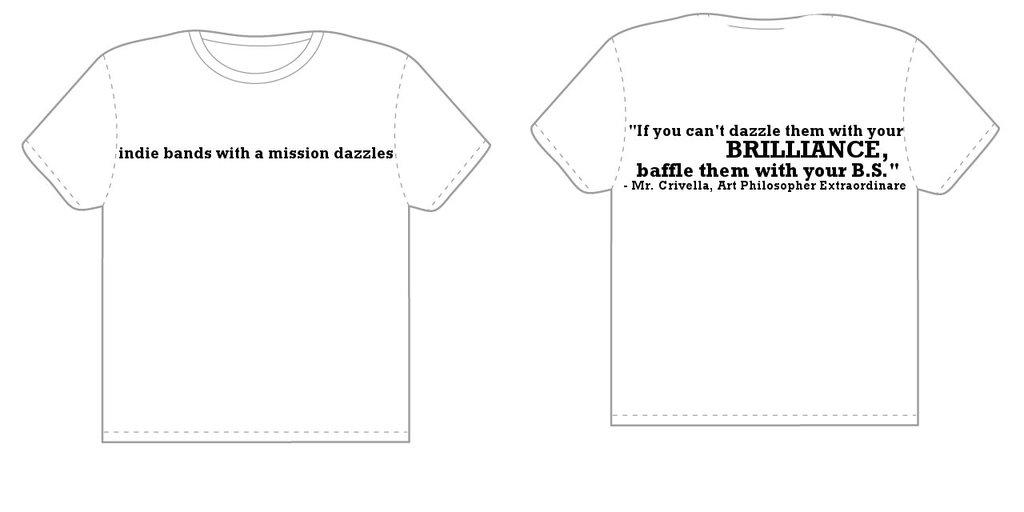<image>
Offer a succinct explanation of the picture presented. Tee shirt blueprints with information about indie bands on them. 